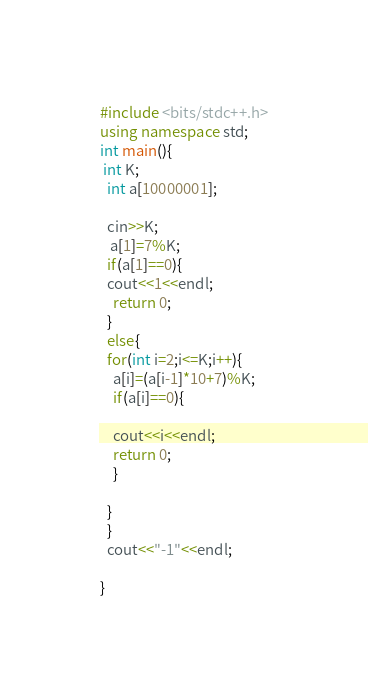Convert code to text. <code><loc_0><loc_0><loc_500><loc_500><_C++_>#include <bits/stdc++.h>
using namespace std;
int main(){
 int K;
  int a[10000001];
 
  cin>>K;
   a[1]=7%K;
  if(a[1]==0){
  cout<<1<<endl;
    return 0;
  }
  else{
  for(int i=2;i<=K;i++){
    a[i]=(a[i-1]*10+7)%K;
    if(a[i]==0){
      
    cout<<i<<endl;
    return 0;
    }
    
  }
  }
  cout<<"-1"<<endl;
  
}
</code> 